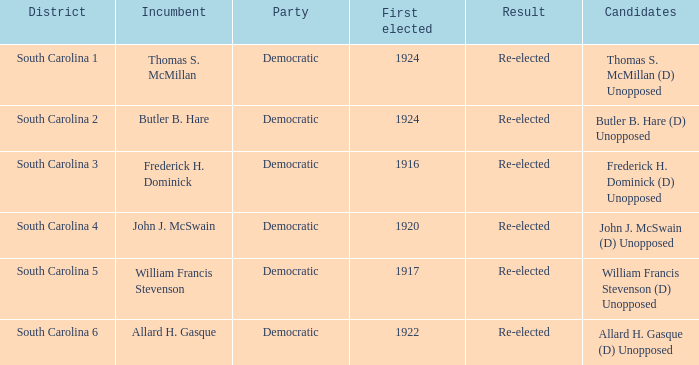What is the party for south carolina 3? Democratic. 